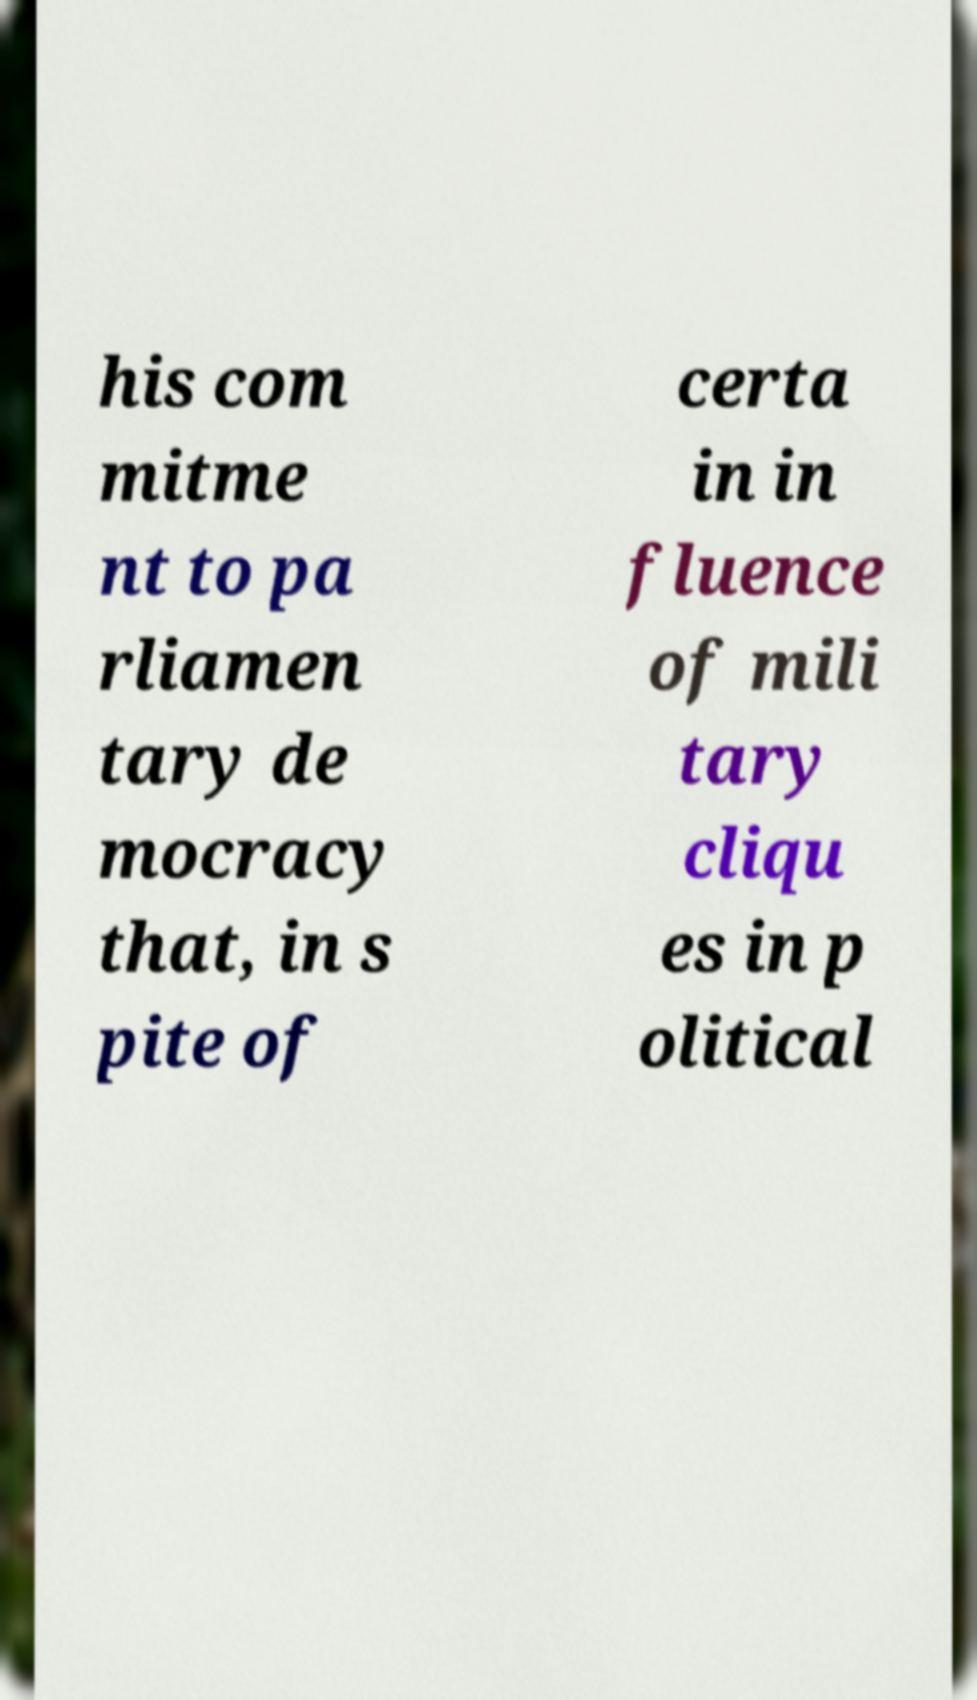I need the written content from this picture converted into text. Can you do that? his com mitme nt to pa rliamen tary de mocracy that, in s pite of certa in in fluence of mili tary cliqu es in p olitical 